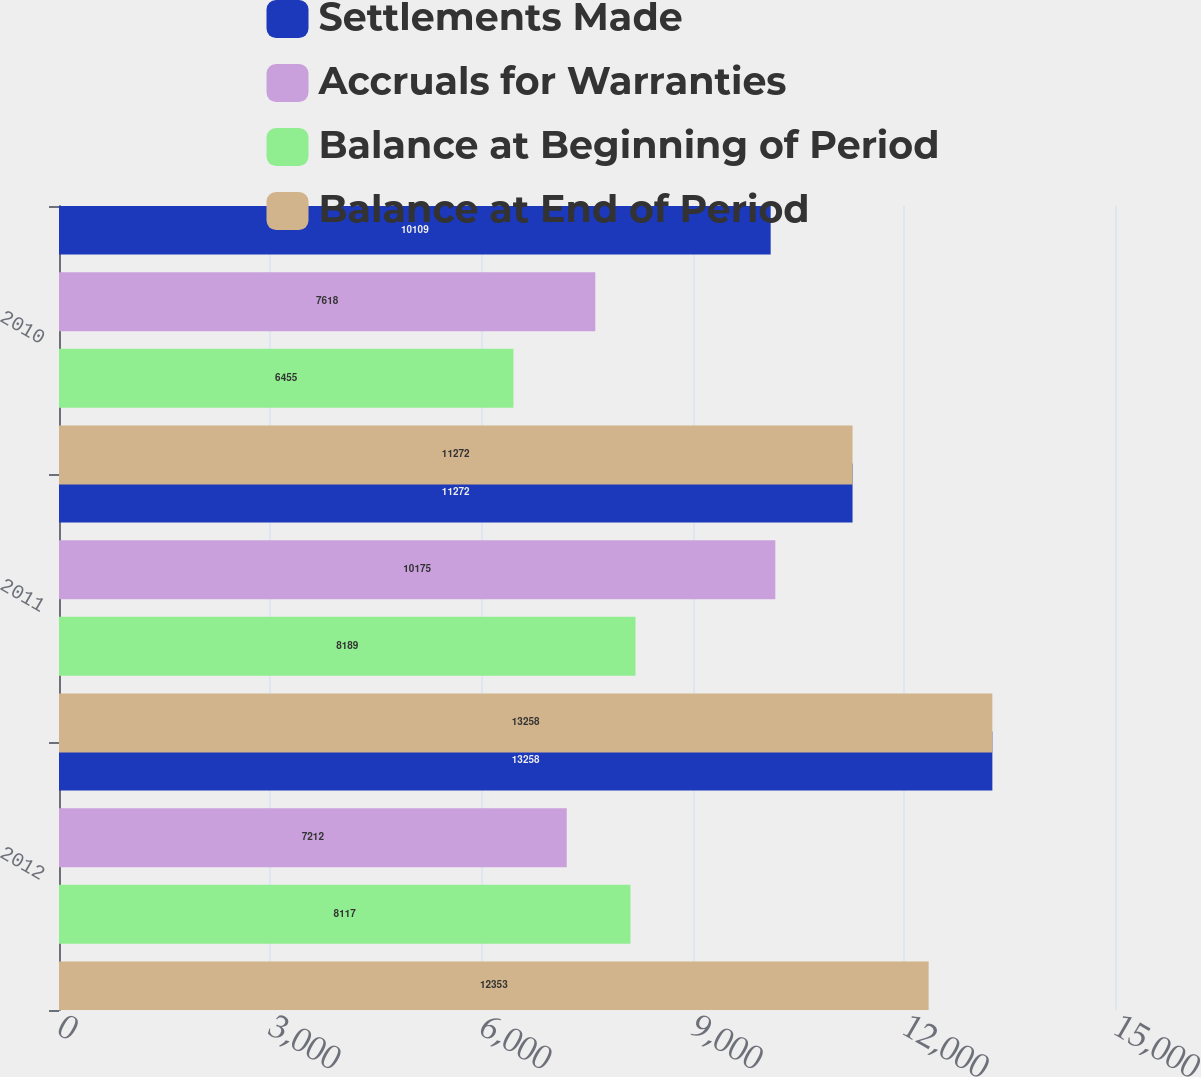<chart> <loc_0><loc_0><loc_500><loc_500><stacked_bar_chart><ecel><fcel>2012<fcel>2011<fcel>2010<nl><fcel>Settlements Made<fcel>13258<fcel>11272<fcel>10109<nl><fcel>Accruals for Warranties<fcel>7212<fcel>10175<fcel>7618<nl><fcel>Balance at Beginning of Period<fcel>8117<fcel>8189<fcel>6455<nl><fcel>Balance at End of Period<fcel>12353<fcel>13258<fcel>11272<nl></chart> 